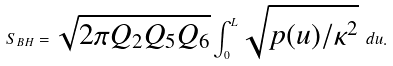<formula> <loc_0><loc_0><loc_500><loc_500>S _ { B H } = \sqrt { 2 \pi Q _ { 2 } Q _ { 5 } Q _ { 6 } } \int _ { 0 } ^ { L } \sqrt { p ( u ) / \kappa ^ { 2 } } \ d u .</formula> 